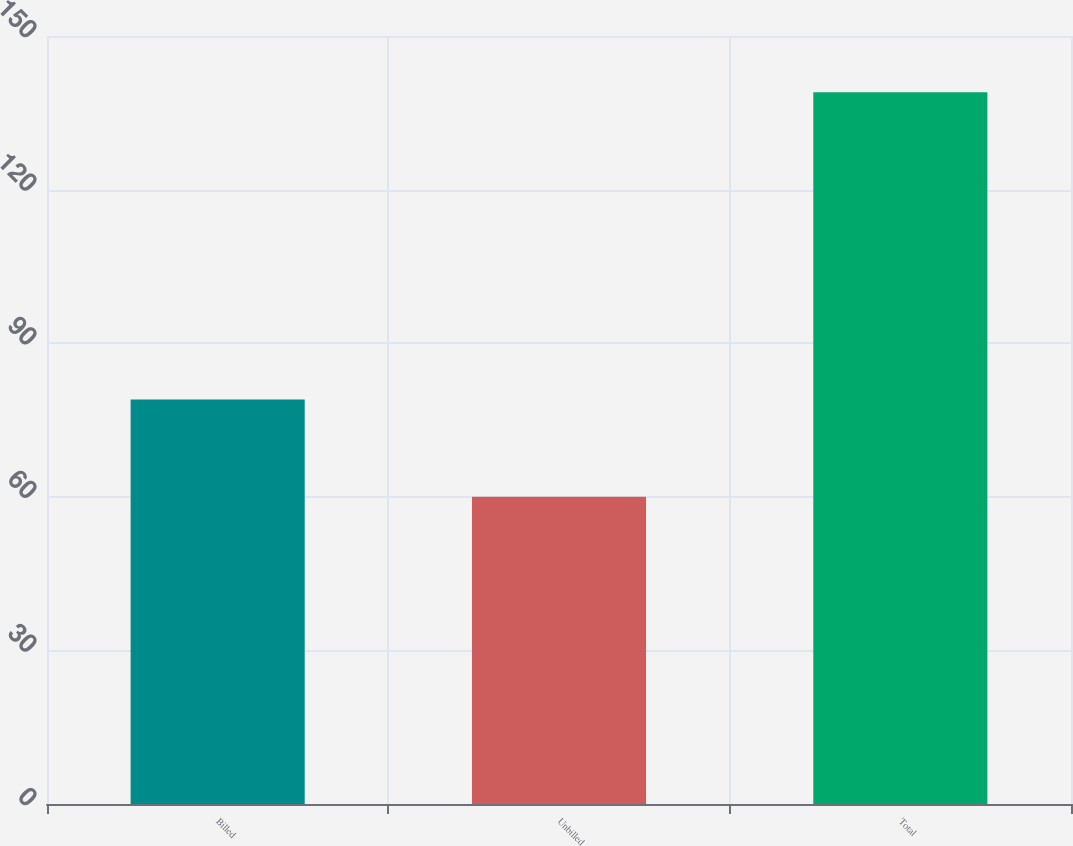<chart> <loc_0><loc_0><loc_500><loc_500><bar_chart><fcel>Billed<fcel>Unbilled<fcel>Total<nl><fcel>79<fcel>60<fcel>139<nl></chart> 